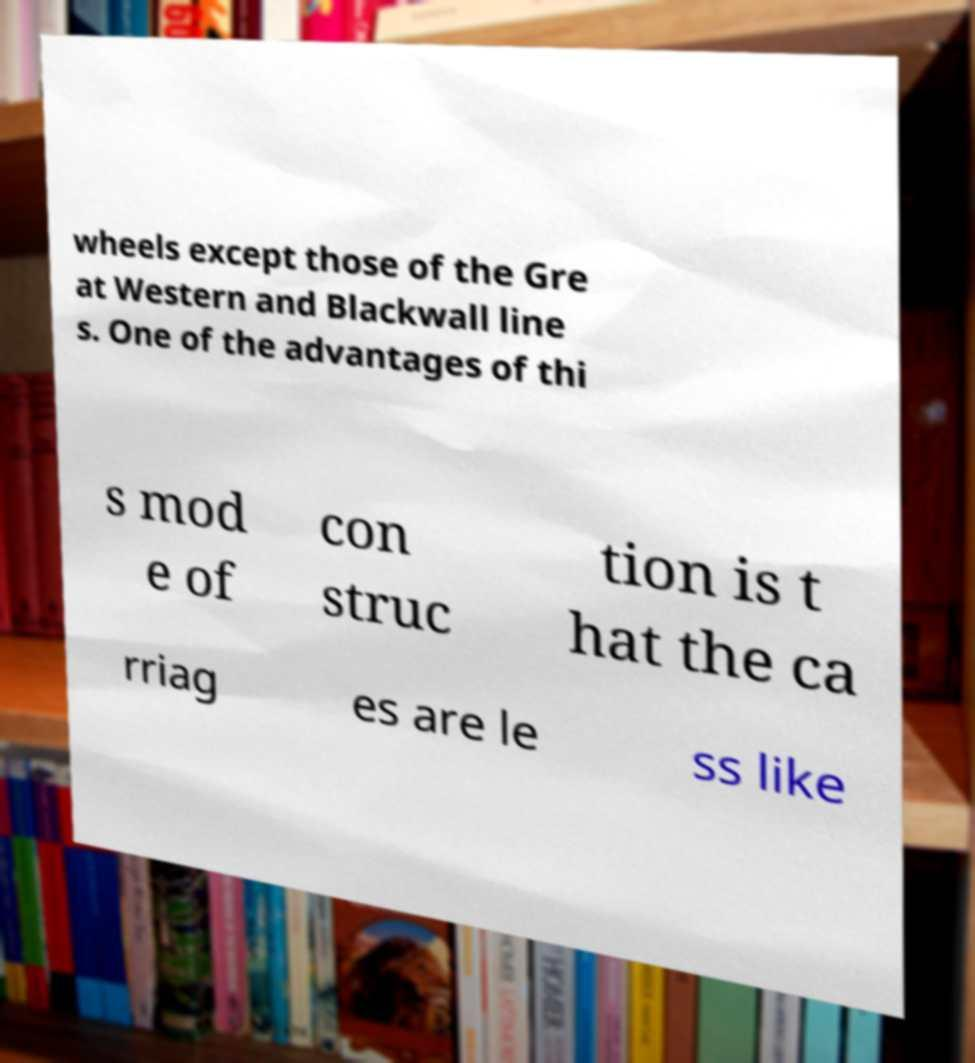There's text embedded in this image that I need extracted. Can you transcribe it verbatim? wheels except those of the Gre at Western and Blackwall line s. One of the advantages of thi s mod e of con struc tion is t hat the ca rriag es are le ss like 